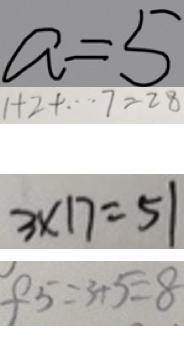Convert formula to latex. <formula><loc_0><loc_0><loc_500><loc_500>a = 5 
 1 + 2 + \cdots 7 = 2 8 
 3 \times 1 7 = 5 1 
 f 5 = 3 + 5 = 8</formula> 